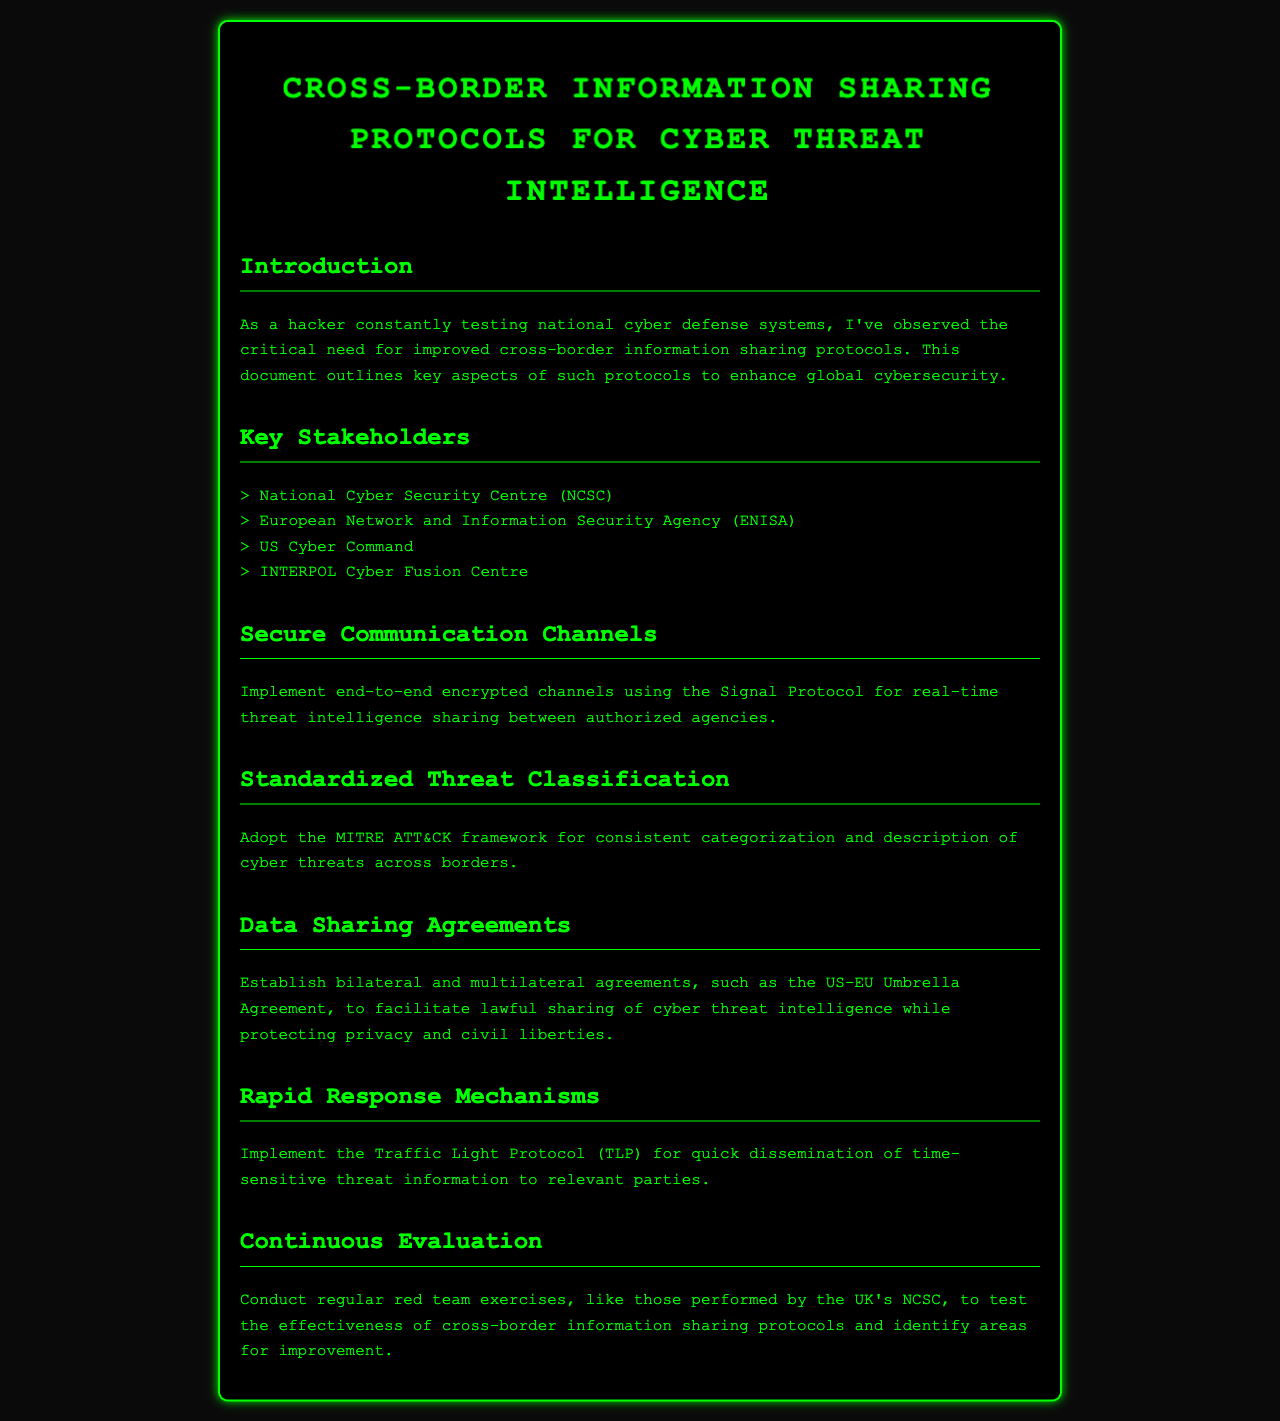What is the title of the document? The title is stated at the beginning of the document and provides the main topic covered.
Answer: Cross-Border Information Sharing Protocols for Cyber Threat Intelligence Who are the key stakeholders mentioned? The document lists organizations involved in cyber threat intelligence sharing as key stakeholders.
Answer: National Cyber Security Centre, European Network and Information Security Agency, US Cyber Command, INTERPOL Cyber Fusion Centre What communication protocol is recommended for secure channels? The document specifies a protocol to be used for secure communication in threat intelligence sharing.
Answer: Signal Protocol What framework is suggested for threat classification? The document recommends a specific framework for consistent categorization of cyber threats.
Answer: MITRE ATT&CK framework What mechanism is proposed for rapid information dissemination? The document introduces a specific protocol to be used for quick communication of time-sensitive threat information.
Answer: Traffic Light Protocol What type of agreements should be established for data sharing? The document discusses the necessity of specific types of agreements to facilitate lawful sharing of cyber threat intelligence.
Answer: Bilateral and multilateral agreements What evaluation method is advised for testing protocols? The document mentions a type of exercise that can be conducted regularly to evaluate the effectiveness of the protocols.
Answer: Red team exercises 